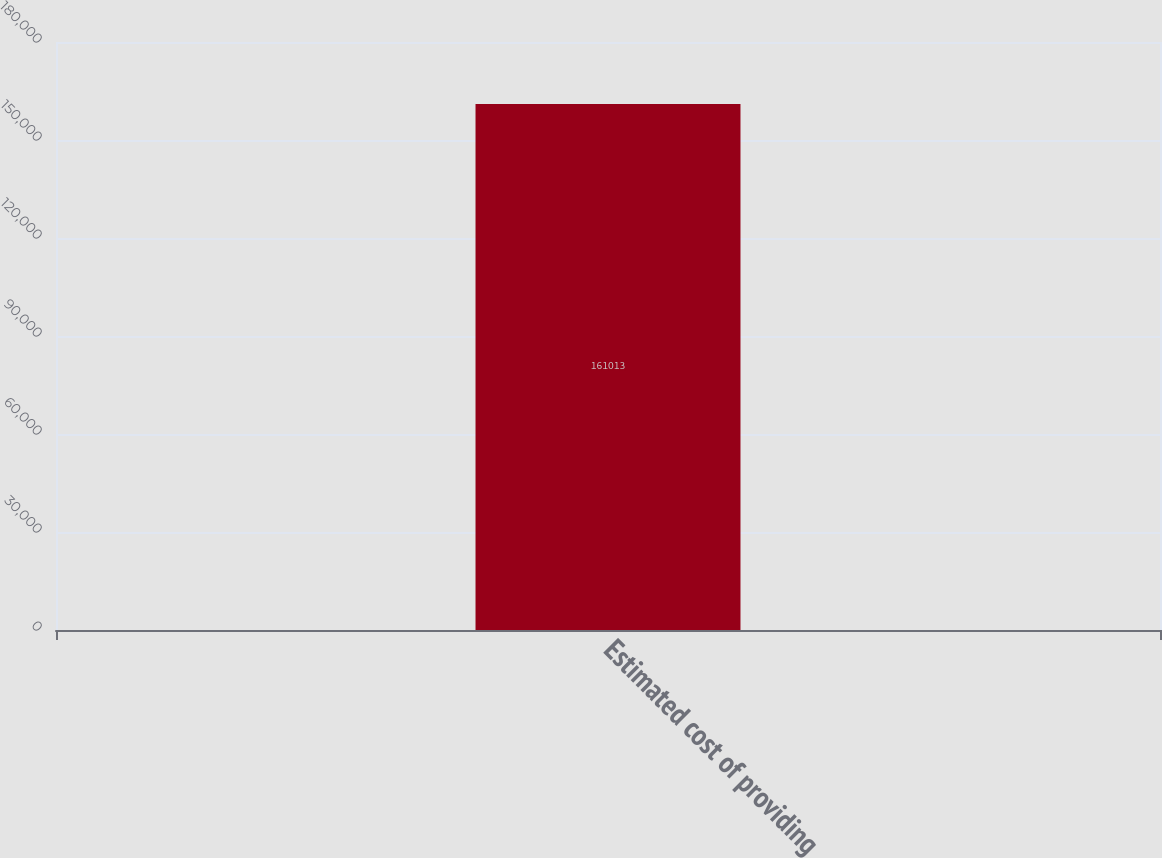Convert chart. <chart><loc_0><loc_0><loc_500><loc_500><bar_chart><fcel>Estimated cost of providing<nl><fcel>161013<nl></chart> 